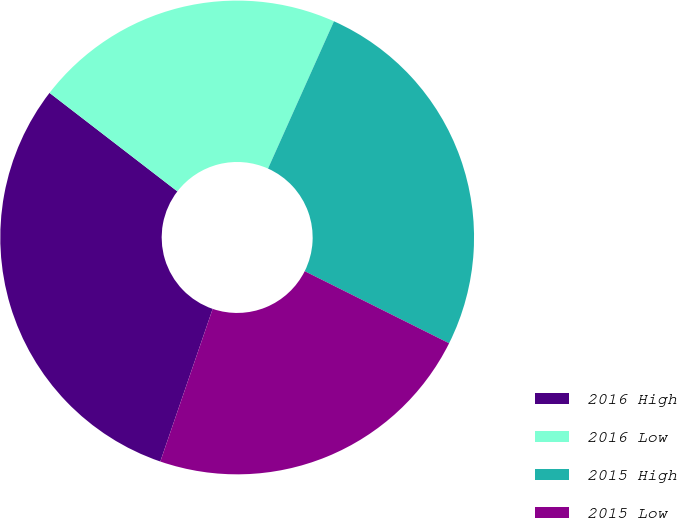Convert chart to OTSL. <chart><loc_0><loc_0><loc_500><loc_500><pie_chart><fcel>2016 High<fcel>2016 Low<fcel>2015 High<fcel>2015 Low<nl><fcel>30.19%<fcel>21.25%<fcel>25.67%<fcel>22.89%<nl></chart> 